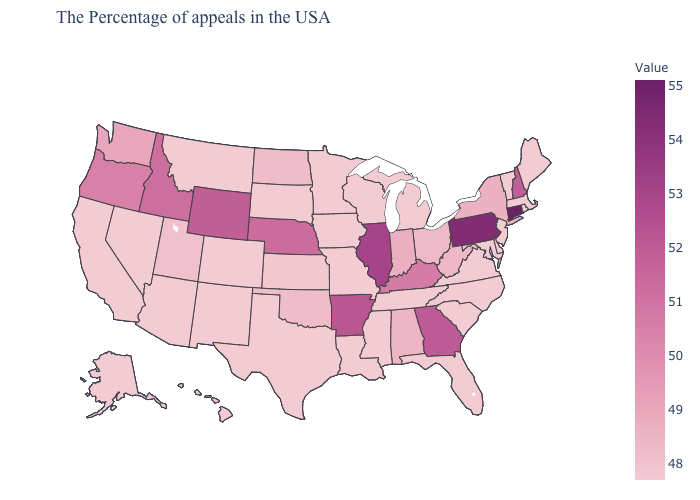Does Michigan have the lowest value in the USA?
Answer briefly. Yes. Which states hav the highest value in the West?
Give a very brief answer. Wyoming. Among the states that border South Carolina , does North Carolina have the lowest value?
Answer briefly. Yes. Which states hav the highest value in the Northeast?
Be succinct. Connecticut. Which states have the lowest value in the South?
Quick response, please. Delaware, Maryland, Virginia, North Carolina, South Carolina, Florida, Tennessee, Mississippi, Louisiana, Texas. Among the states that border Massachusetts , does Vermont have the highest value?
Short answer required. No. 